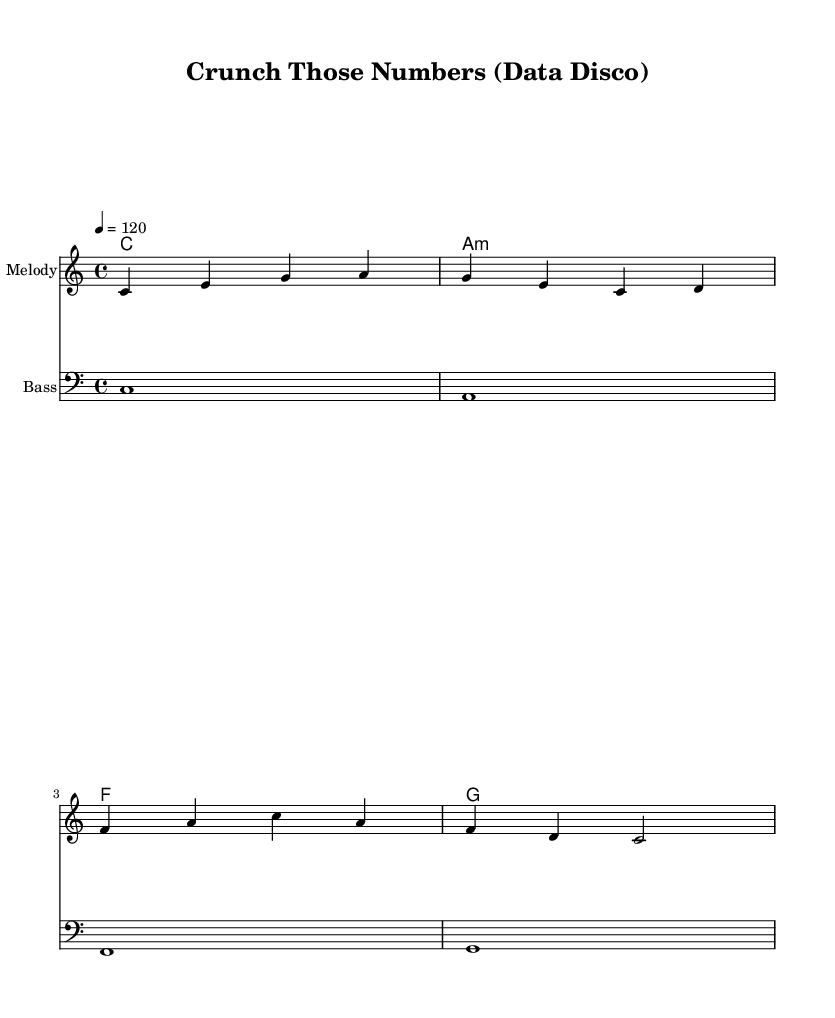What is the key signature of this music? The key signature is indicated at the beginning of the score. It shows no sharps or flats, indicating that it is in C major.
Answer: C major What is the time signature of this piece? The time signature is shown at the beginning of the score, which is 4/4. This means there are four beats in each measure.
Answer: 4/4 What is the tempo marking for this score? The tempo marking is shown following the global settings. It is indicated as "4 = 120," meaning there are 120 beats per minute.
Answer: 120 How many measures are there in the melody? By counting the measures in the melody section, we see there are four measures present.
Answer: 4 What type of harmony is used in this piece? The harmony is primarily based on chords, which are indicated by the chord names. They include C major, A minor, F major, and G major.
Answer: Chord-based What is the rhythmic structure of the bass part? The bass part shows continual whole notes (indicated by the "1" in each chord), suggesting a steady and simple rhythm supporting the harmonic structure.
Answer: Whole notes What stylistic elements are present that classify this song as disco? The song features an upbeat tempo, a four-on-the-floor beat likely implied by the steady rhythm, and a catchy, repetitive melody typical of disco music.
Answer: Upbeat tempo and repetitive melody 